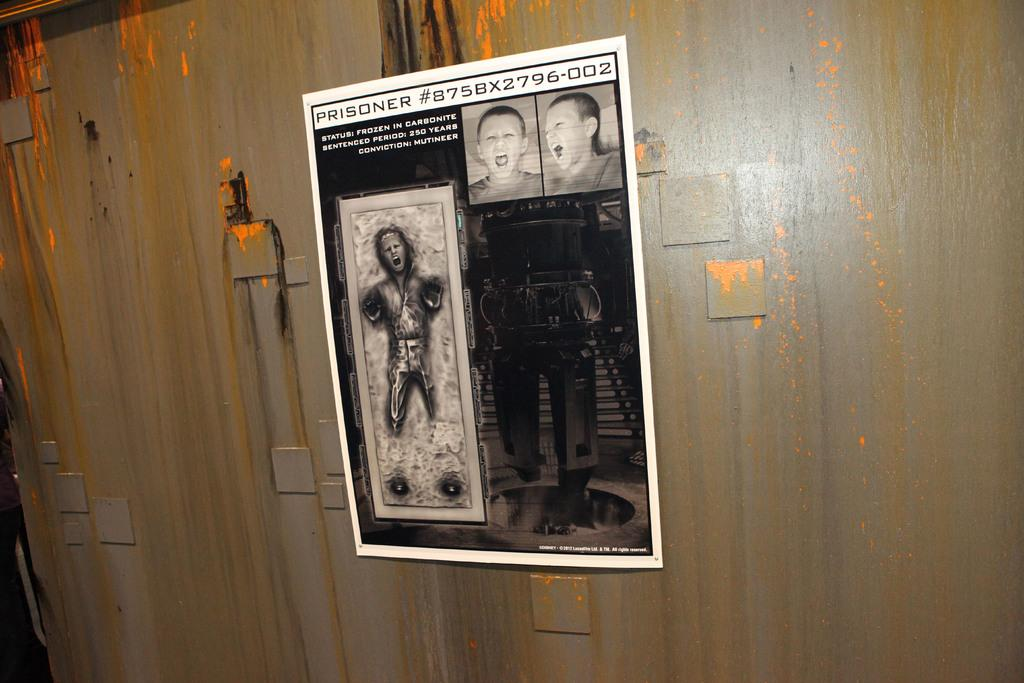<image>
Render a clear and concise summary of the photo. The scary picture on the wall is of Prisoner #875BX2796-002 